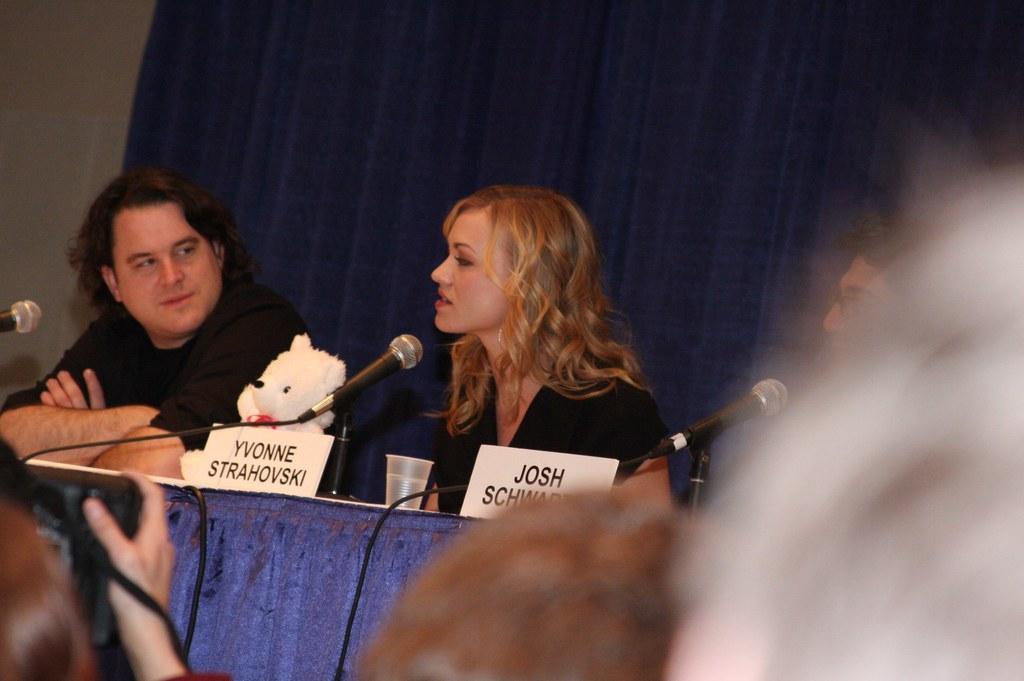Could you give a brief overview of what you see in this image? In this image, we can see a table and there are some black color microphone, we can see some people sitting and in the background there is a blue color curtain. 